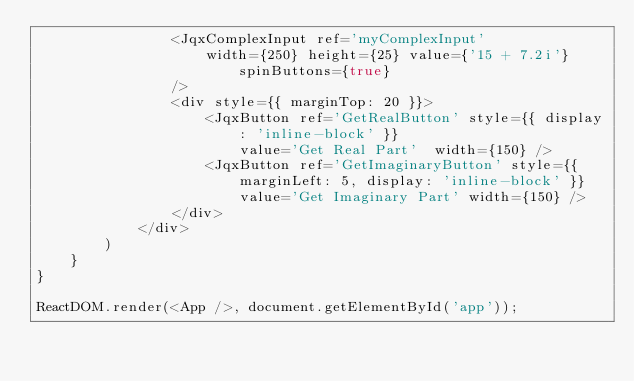Convert code to text. <code><loc_0><loc_0><loc_500><loc_500><_JavaScript_>                <JqxComplexInput ref='myComplexInput'
                    width={250} height={25} value={'15 + 7.2i'} spinButtons={true}
                />
                <div style={{ marginTop: 20 }}>
                    <JqxButton ref='GetRealButton' style={{ display: 'inline-block' }}
                        value='Get Real Part'  width={150} />
                    <JqxButton ref='GetImaginaryButton' style={{ marginLeft: 5, display: 'inline-block' }}
                        value='Get Imaginary Part' width={150} />
                </div>
            </div>
        )
    }
}

ReactDOM.render(<App />, document.getElementById('app'));
</code> 